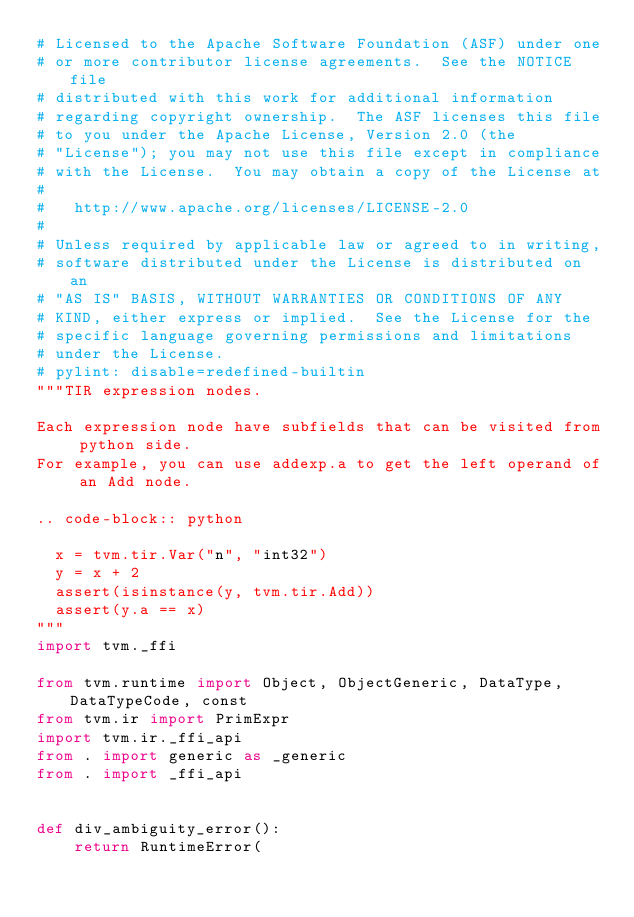<code> <loc_0><loc_0><loc_500><loc_500><_Python_># Licensed to the Apache Software Foundation (ASF) under one
# or more contributor license agreements.  See the NOTICE file
# distributed with this work for additional information
# regarding copyright ownership.  The ASF licenses this file
# to you under the Apache License, Version 2.0 (the
# "License"); you may not use this file except in compliance
# with the License.  You may obtain a copy of the License at
#
#   http://www.apache.org/licenses/LICENSE-2.0
#
# Unless required by applicable law or agreed to in writing,
# software distributed under the License is distributed on an
# "AS IS" BASIS, WITHOUT WARRANTIES OR CONDITIONS OF ANY
# KIND, either express or implied.  See the License for the
# specific language governing permissions and limitations
# under the License.
# pylint: disable=redefined-builtin
"""TIR expression nodes.

Each expression node have subfields that can be visited from python side.
For example, you can use addexp.a to get the left operand of an Add node.

.. code-block:: python

  x = tvm.tir.Var("n", "int32")
  y = x + 2
  assert(isinstance(y, tvm.tir.Add))
  assert(y.a == x)
"""
import tvm._ffi

from tvm.runtime import Object, ObjectGeneric, DataType, DataTypeCode, const
from tvm.ir import PrimExpr
import tvm.ir._ffi_api
from . import generic as _generic
from . import _ffi_api


def div_ambiguity_error():
    return RuntimeError(</code> 